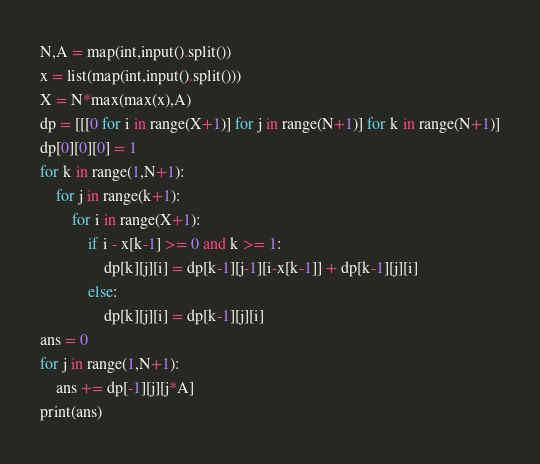<code> <loc_0><loc_0><loc_500><loc_500><_Python_>N,A = map(int,input().split())
x = list(map(int,input().split()))
X = N*max(max(x),A)
dp = [[[0 for i in range(X+1)] for j in range(N+1)] for k in range(N+1)]
dp[0][0][0] = 1
for k in range(1,N+1):
    for j in range(k+1):
        for i in range(X+1):
            if i - x[k-1] >= 0 and k >= 1:
                dp[k][j][i] = dp[k-1][j-1][i-x[k-1]] + dp[k-1][j][i]
            else:
                dp[k][j][i] = dp[k-1][j][i]
ans = 0
for j in range(1,N+1):
    ans += dp[-1][j][j*A]
print(ans)</code> 